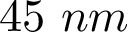Convert formula to latex. <formula><loc_0><loc_0><loc_500><loc_500>4 5 \ n m</formula> 